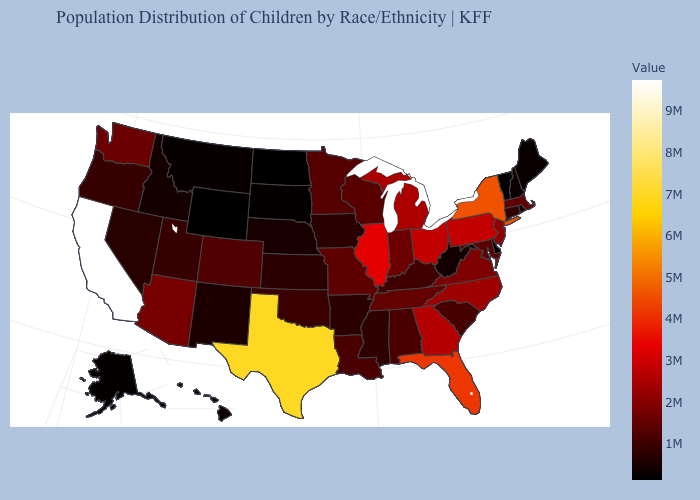Does the map have missing data?
Answer briefly. No. Is the legend a continuous bar?
Concise answer only. Yes. Which states have the highest value in the USA?
Answer briefly. California. Which states have the lowest value in the MidWest?
Give a very brief answer. North Dakota. Among the states that border Maryland , does Pennsylvania have the highest value?
Answer briefly. Yes. 